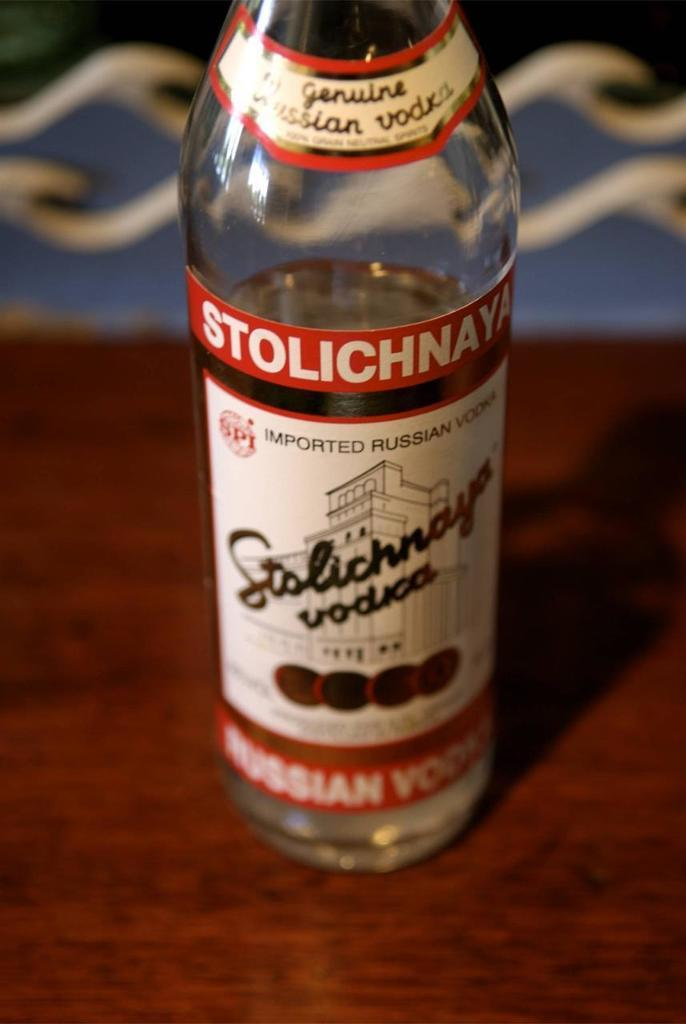<image>
Provide a brief description of the given image. a bottle of STOLICHNAYA vodka alcohol that is opened. 